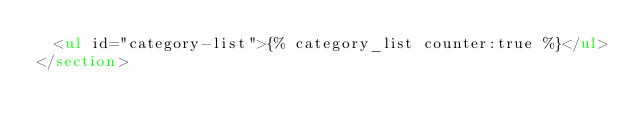<code> <loc_0><loc_0><loc_500><loc_500><_HTML_>  <ul id="category-list">{% category_list counter:true %}</ul>
</section>
</code> 